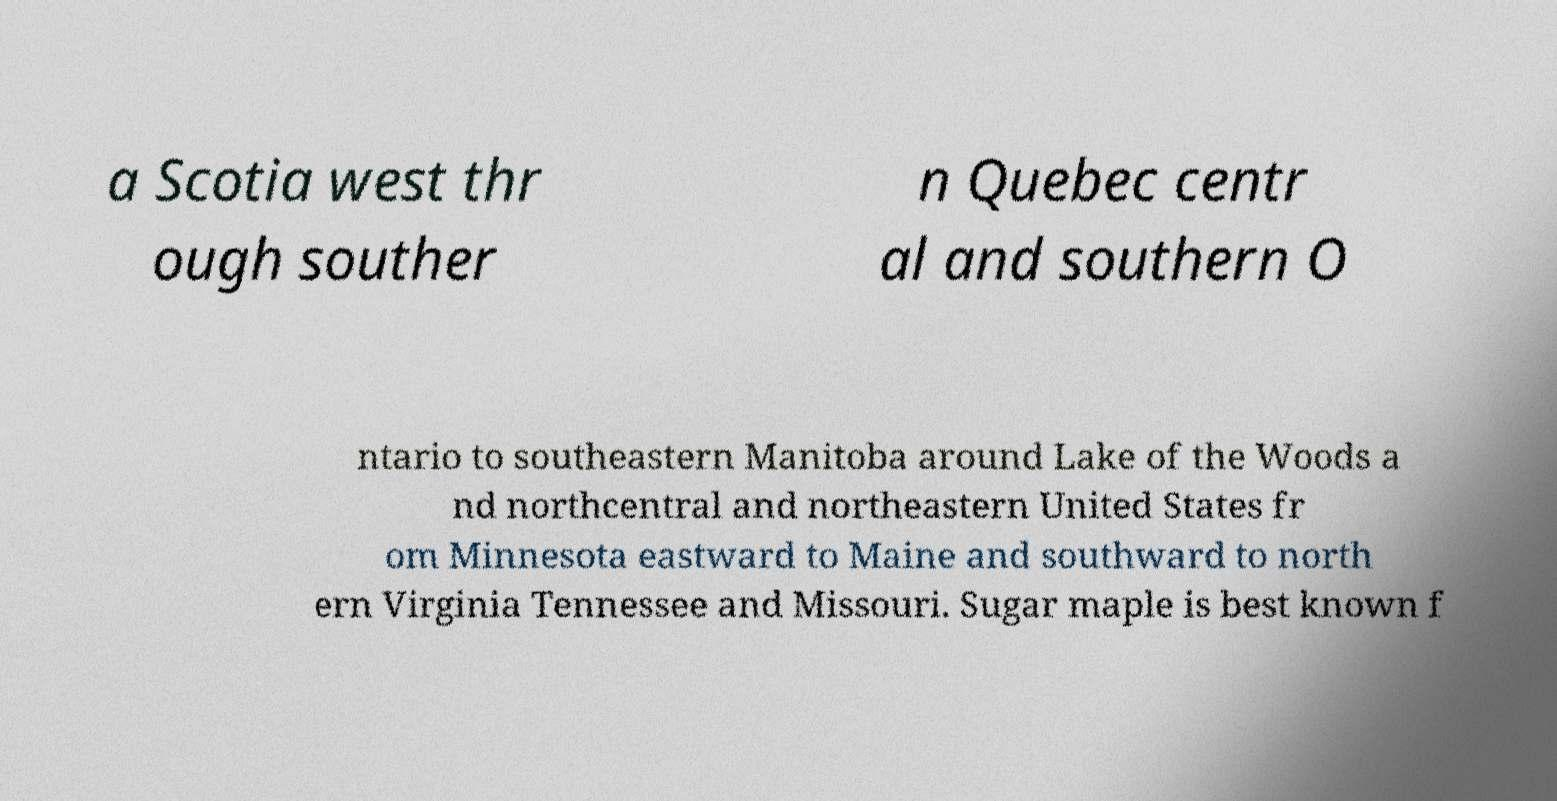Please read and relay the text visible in this image. What does it say? a Scotia west thr ough souther n Quebec centr al and southern O ntario to southeastern Manitoba around Lake of the Woods a nd northcentral and northeastern United States fr om Minnesota eastward to Maine and southward to north ern Virginia Tennessee and Missouri. Sugar maple is best known f 